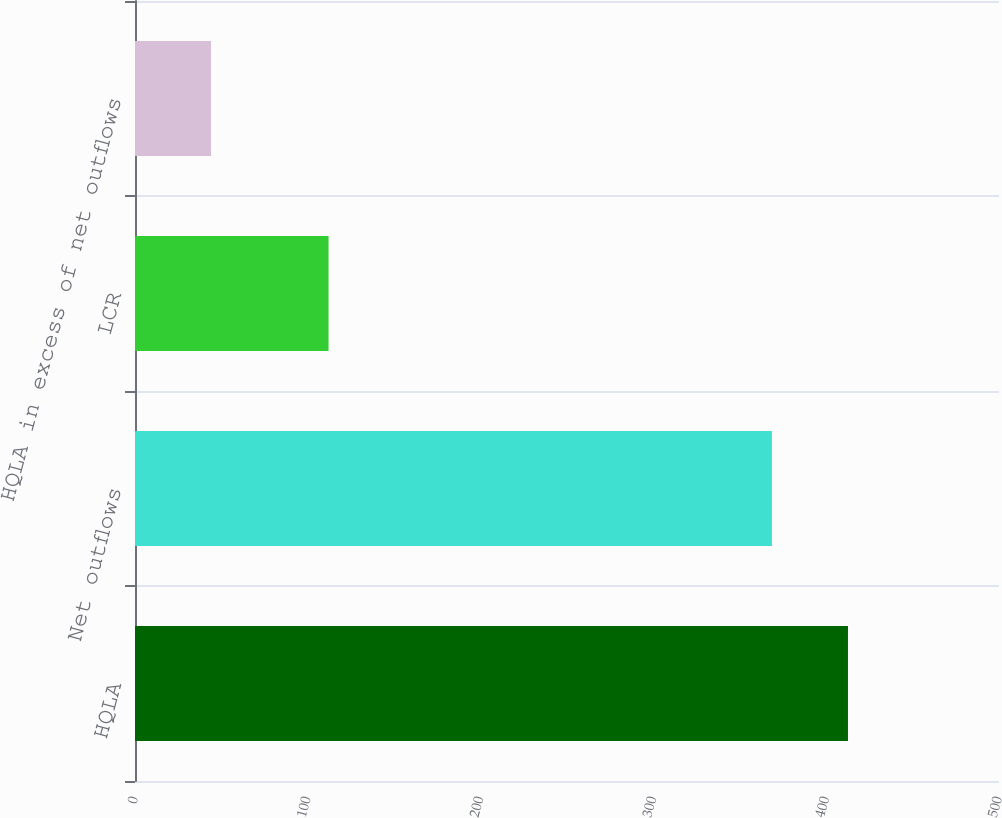Convert chart. <chart><loc_0><loc_0><loc_500><loc_500><bar_chart><fcel>HQLA<fcel>Net outflows<fcel>LCR<fcel>HQLA in excess of net outflows<nl><fcel>412.6<fcel>368.6<fcel>112<fcel>44<nl></chart> 